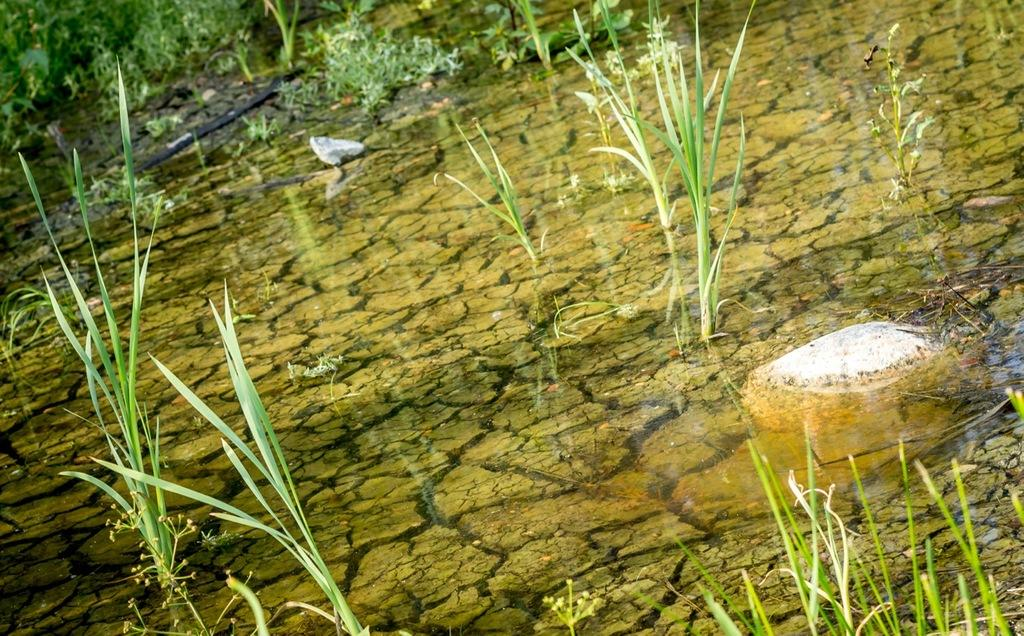What is visible in the image? There is water and grass visible in the image. Are there any plants in the image? Yes, there are plants in the top left corner of the image. What is the price of the coach in the image? There is no coach present in the image, so it is not possible to determine its price. 